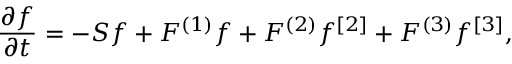<formula> <loc_0><loc_0><loc_500><loc_500>{ \frac { \partial f } { \partial t } } = - S f + F ^ { ( 1 ) } f + F ^ { ( 2 ) } f ^ { [ 2 ] } + F ^ { ( 3 ) } f ^ { [ 3 ] } ,</formula> 